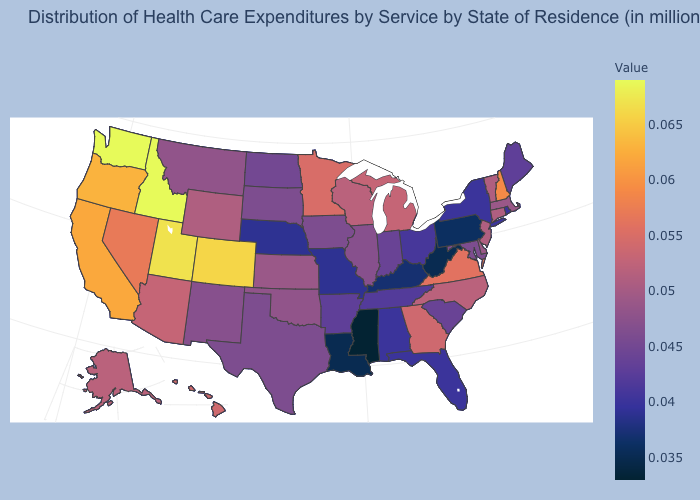Which states have the highest value in the USA?
Be succinct. Idaho, Washington. Which states have the lowest value in the USA?
Write a very short answer. Mississippi. Does Minnesota have the highest value in the MidWest?
Short answer required. Yes. Which states have the highest value in the USA?
Give a very brief answer. Idaho, Washington. Does the map have missing data?
Be succinct. No. Among the states that border Delaware , does New Jersey have the highest value?
Write a very short answer. Yes. Which states have the highest value in the USA?
Concise answer only. Idaho, Washington. 